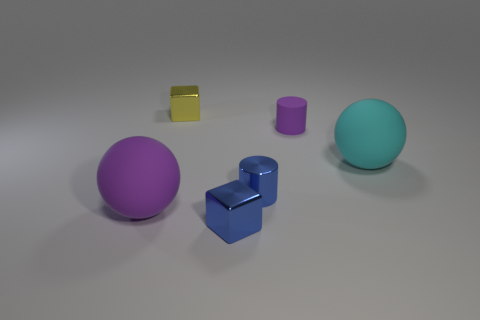Subtract all yellow balls. Subtract all yellow cylinders. How many balls are left? 2 Add 2 big balls. How many objects exist? 8 Subtract all spheres. How many objects are left? 4 Subtract all large cyan spheres. Subtract all purple things. How many objects are left? 3 Add 4 purple matte cylinders. How many purple matte cylinders are left? 5 Add 4 tiny purple matte things. How many tiny purple matte things exist? 5 Subtract 0 brown cylinders. How many objects are left? 6 